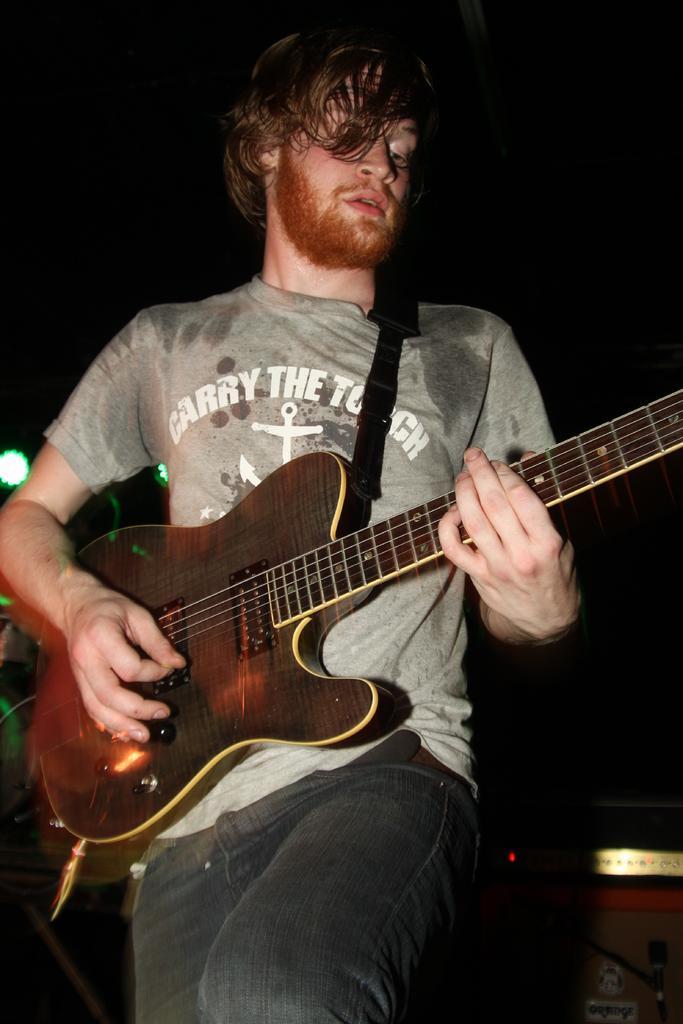Please provide a concise description of this image. In this picture there is a person playing guitar, behind him there are music control systems. At the top, in the background it is dark. 